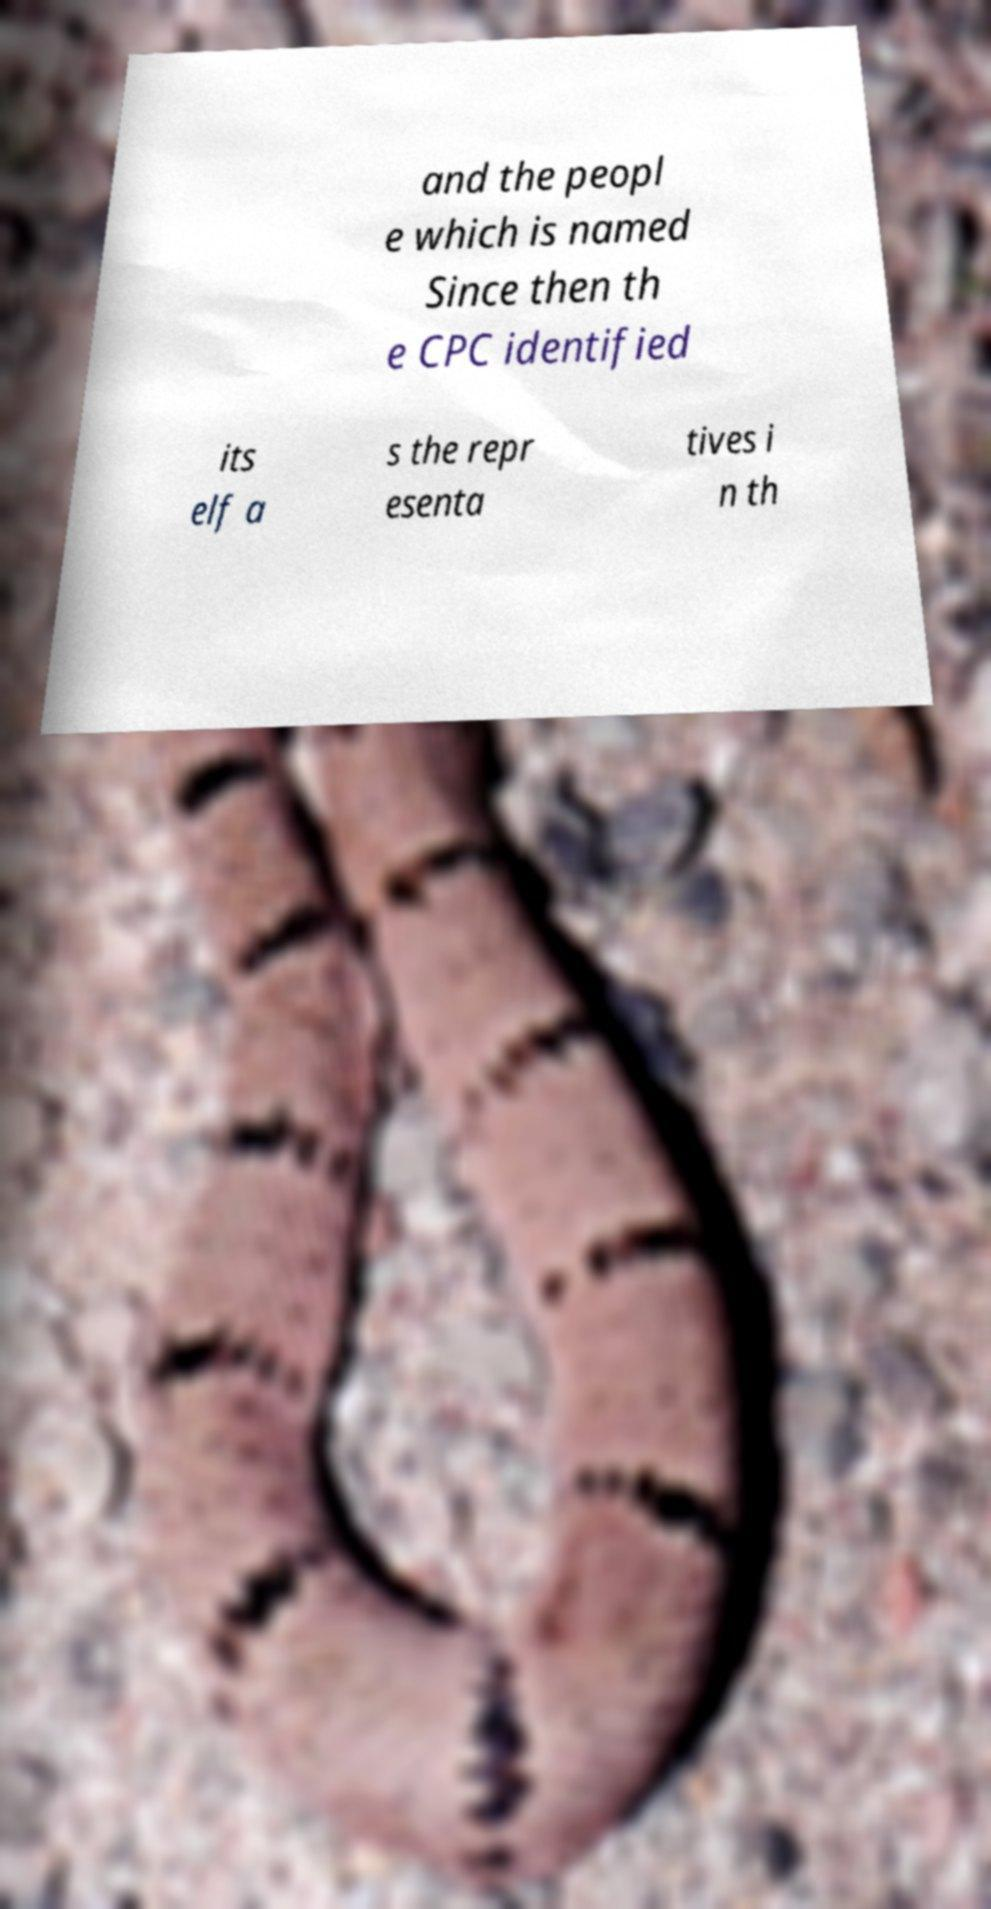There's text embedded in this image that I need extracted. Can you transcribe it verbatim? and the peopl e which is named Since then th e CPC identified its elf a s the repr esenta tives i n th 